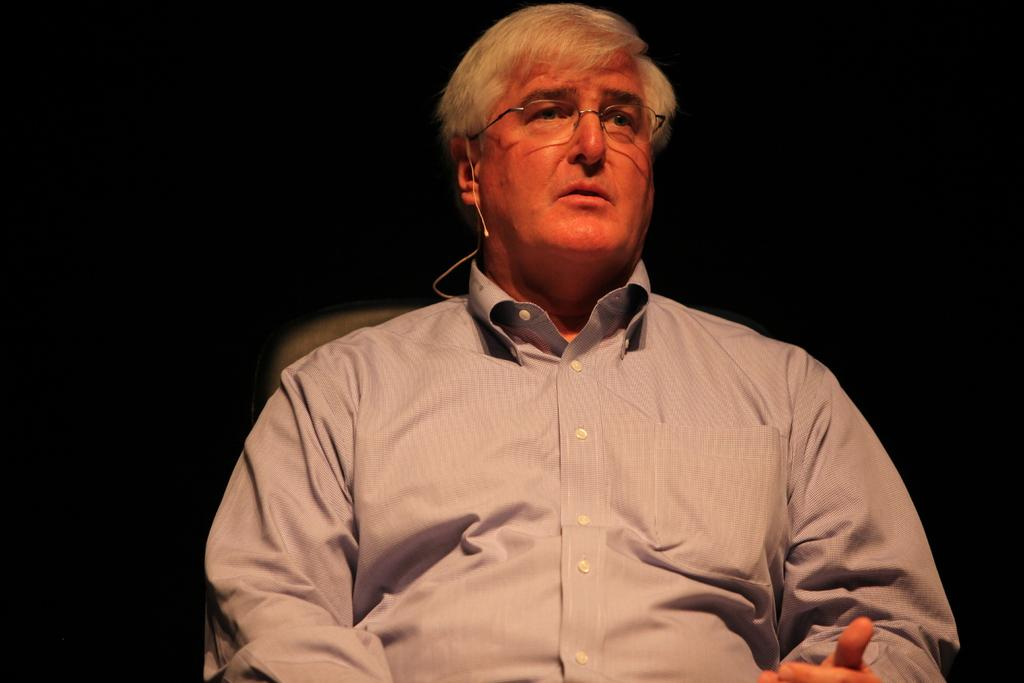Who is the main subject in the image? There is a man in the middle of the picture. What is the man wearing in the image? The man is wearing spectacles. What can be observed about the background of the image? The background of the image is completely dark. Can you see the mom of the man in the image? There is no indication of a mom or any other person besides the man in the image. What type of building is visible in the background of the image? There is no building visible in the image, as the background is completely dark. 